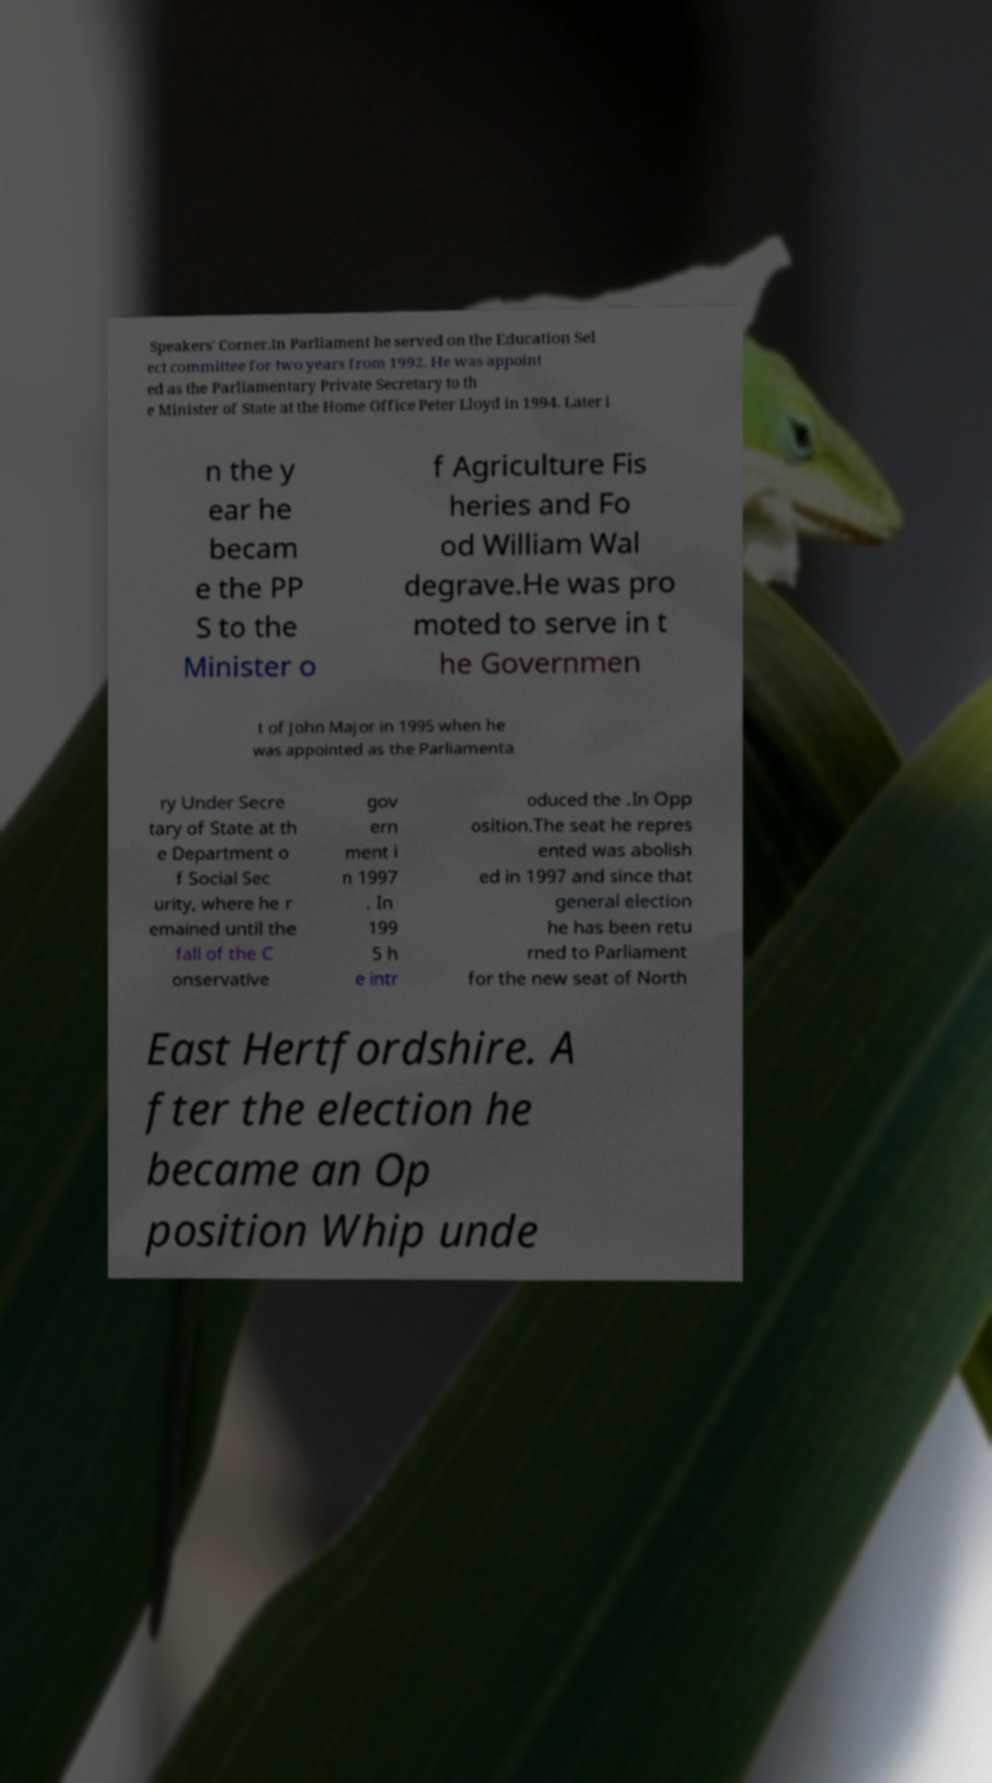I need the written content from this picture converted into text. Can you do that? Speakers' Corner.In Parliament he served on the Education Sel ect committee for two years from 1992. He was appoint ed as the Parliamentary Private Secretary to th e Minister of State at the Home Office Peter Lloyd in 1994. Later i n the y ear he becam e the PP S to the Minister o f Agriculture Fis heries and Fo od William Wal degrave.He was pro moted to serve in t he Governmen t of John Major in 1995 when he was appointed as the Parliamenta ry Under Secre tary of State at th e Department o f Social Sec urity, where he r emained until the fall of the C onservative gov ern ment i n 1997 . In 199 5 h e intr oduced the .In Opp osition.The seat he repres ented was abolish ed in 1997 and since that general election he has been retu rned to Parliament for the new seat of North East Hertfordshire. A fter the election he became an Op position Whip unde 